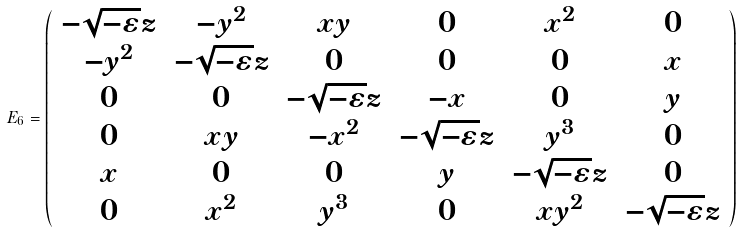Convert formula to latex. <formula><loc_0><loc_0><loc_500><loc_500>E _ { 6 } = \left ( \begin{array} { c c c c c c } - \sqrt { - \varepsilon } z & - y ^ { 2 } & x y & 0 & x ^ { 2 } & 0 \\ - y ^ { 2 } & - \sqrt { - \varepsilon } z & 0 & 0 & 0 & x \\ 0 & 0 & - \sqrt { - \varepsilon } z & - x & 0 & y \\ 0 & x y & - x ^ { 2 } & - \sqrt { - \varepsilon } z & y ^ { 3 } & 0 \\ x & 0 & 0 & y & - \sqrt { - \varepsilon } z & 0 \\ 0 & x ^ { 2 } & y ^ { 3 } & 0 & x y ^ { 2 } & - \sqrt { - \varepsilon } z \end{array} \right )</formula> 